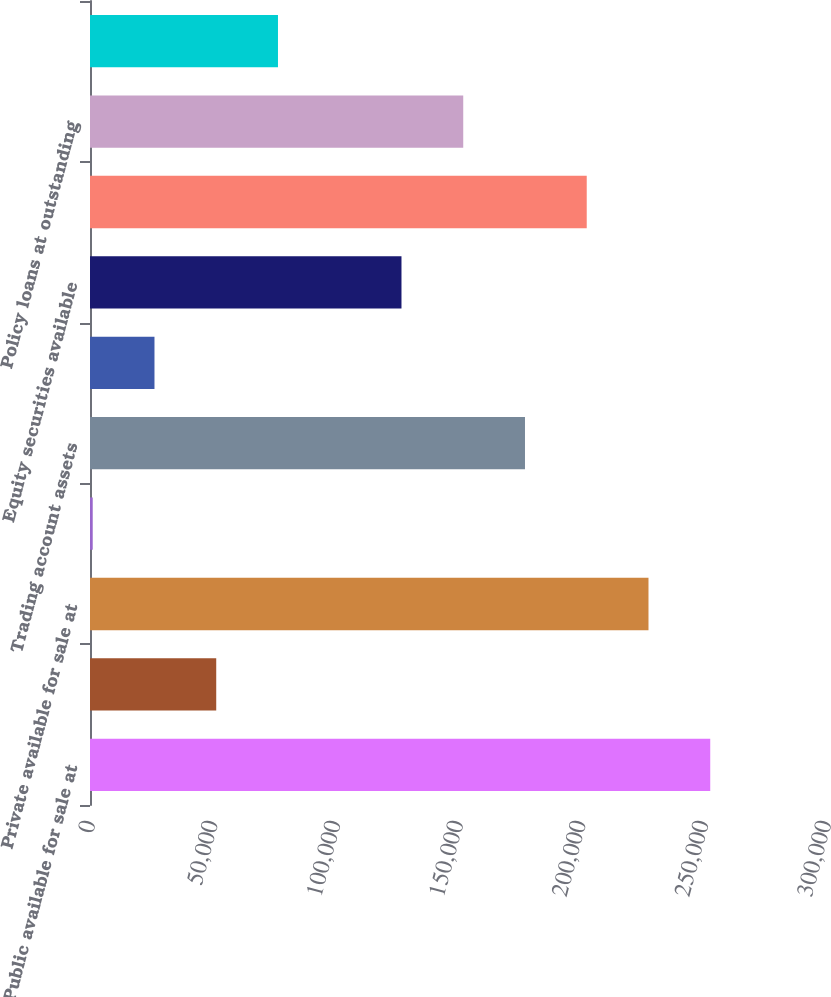<chart> <loc_0><loc_0><loc_500><loc_500><bar_chart><fcel>Public available for sale at<fcel>Public held to maturity at<fcel>Private available for sale at<fcel>Private held to maturity at<fcel>Trading account assets<fcel>Other trading account assets<fcel>Equity securities available<fcel>Commercial mortgage and other<fcel>Policy loans at outstanding<fcel>Other long-term investments(1)<nl><fcel>252815<fcel>51451.8<fcel>227645<fcel>1111<fcel>177304<fcel>26281.4<fcel>126963<fcel>202474<fcel>152133<fcel>76622.2<nl></chart> 